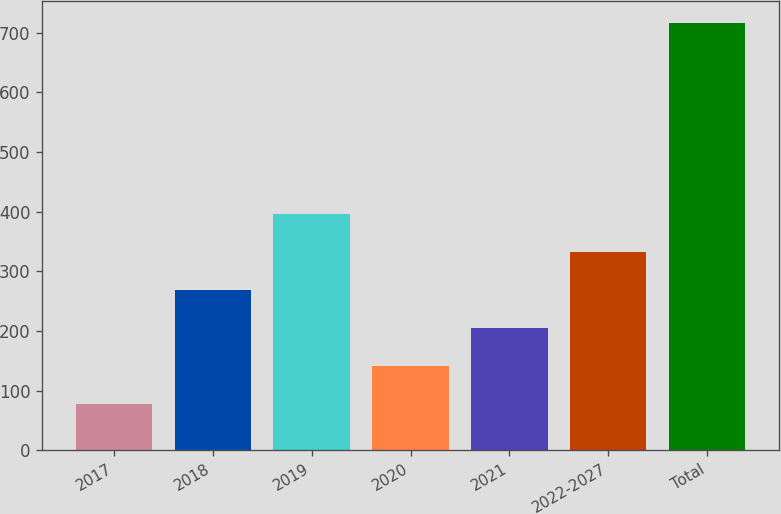<chart> <loc_0><loc_0><loc_500><loc_500><bar_chart><fcel>2017<fcel>2018<fcel>2019<fcel>2020<fcel>2021<fcel>2022-2027<fcel>Total<nl><fcel>77<fcel>269<fcel>397<fcel>141<fcel>205<fcel>333<fcel>717<nl></chart> 